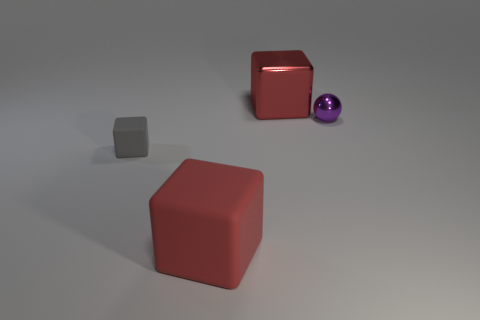Subtract all matte blocks. How many blocks are left? 1 Subtract 1 cubes. How many cubes are left? 2 Add 2 large red shiny cubes. How many objects exist? 6 Subtract all balls. How many objects are left? 3 Add 3 red cubes. How many red cubes are left? 5 Add 3 tiny metallic spheres. How many tiny metallic spheres exist? 4 Subtract 1 gray blocks. How many objects are left? 3 Subtract all small yellow matte balls. Subtract all gray things. How many objects are left? 3 